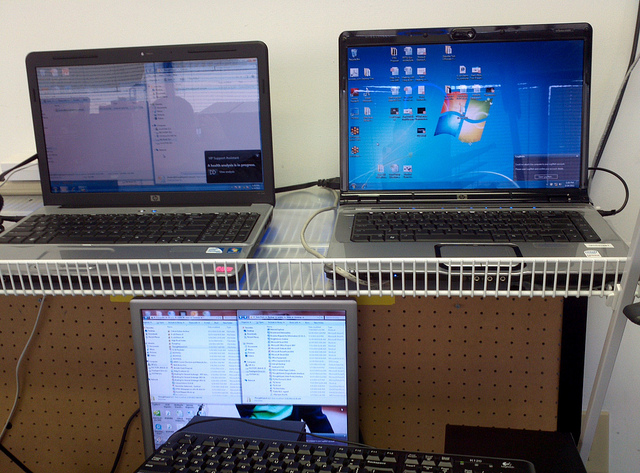What can you tell me about the workspace setup? This workspace features a multi-tiered desk with an ergonomic monitor placement. The monitors are arranged to make the most of vertical space, aiding productivity and organization. The setup suggests someone who needs to monitor multiple tasks or systems simultaneously, likely in a technical or professional context. Is there anything unique about the placement of the screens? Yes, the staggered arrangement where one screen is placed below the others is distinctive. It maximizes desk space and potentially enhances focus by separating tasks visually. This non-traditional setup may also help in reducing neck strain and eye movement when switching between tasks. 